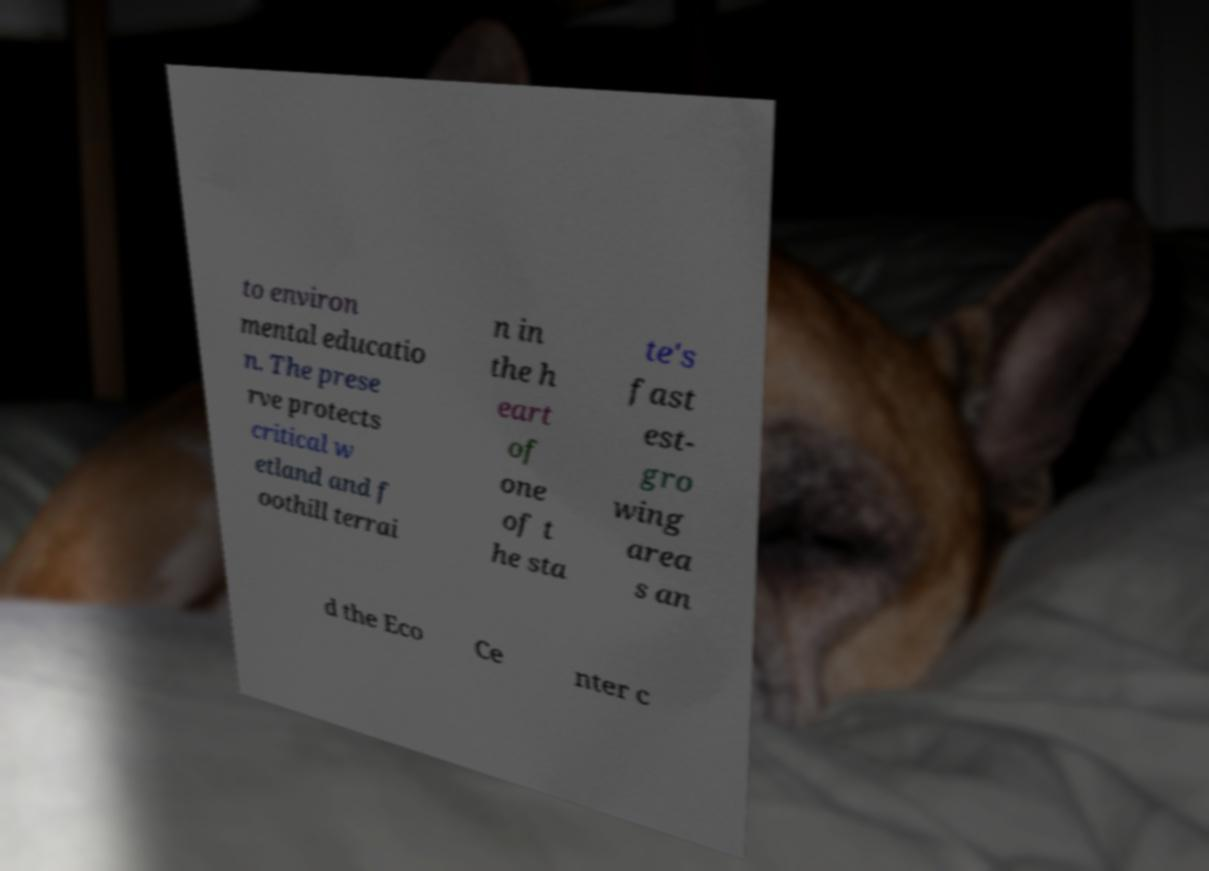I need the written content from this picture converted into text. Can you do that? to environ mental educatio n. The prese rve protects critical w etland and f oothill terrai n in the h eart of one of t he sta te's fast est- gro wing area s an d the Eco Ce nter c 